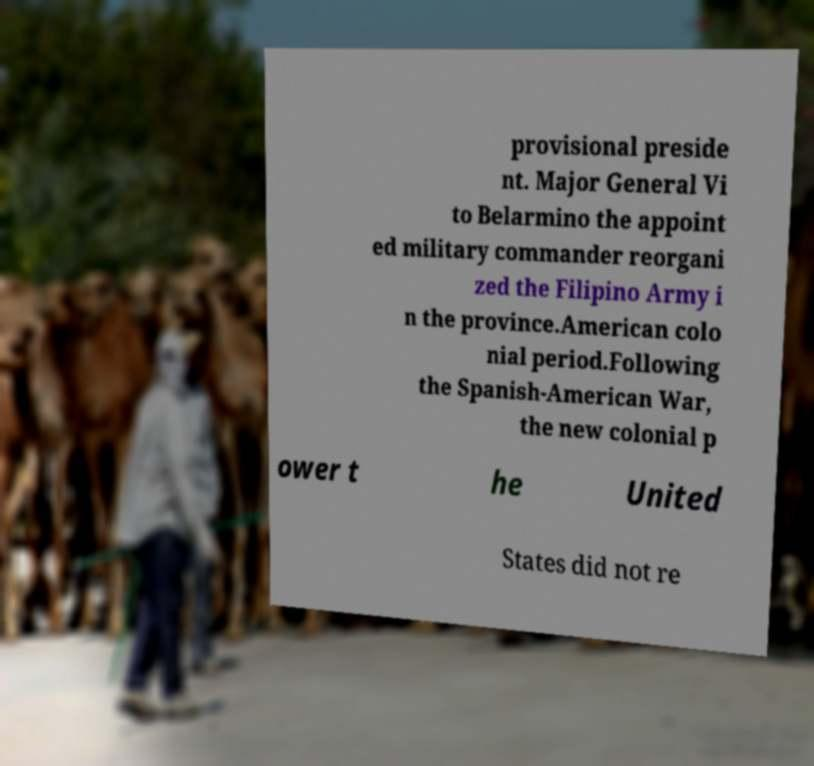Please identify and transcribe the text found in this image. provisional preside nt. Major General Vi to Belarmino the appoint ed military commander reorgani zed the Filipino Army i n the province.American colo nial period.Following the Spanish-American War, the new colonial p ower t he United States did not re 